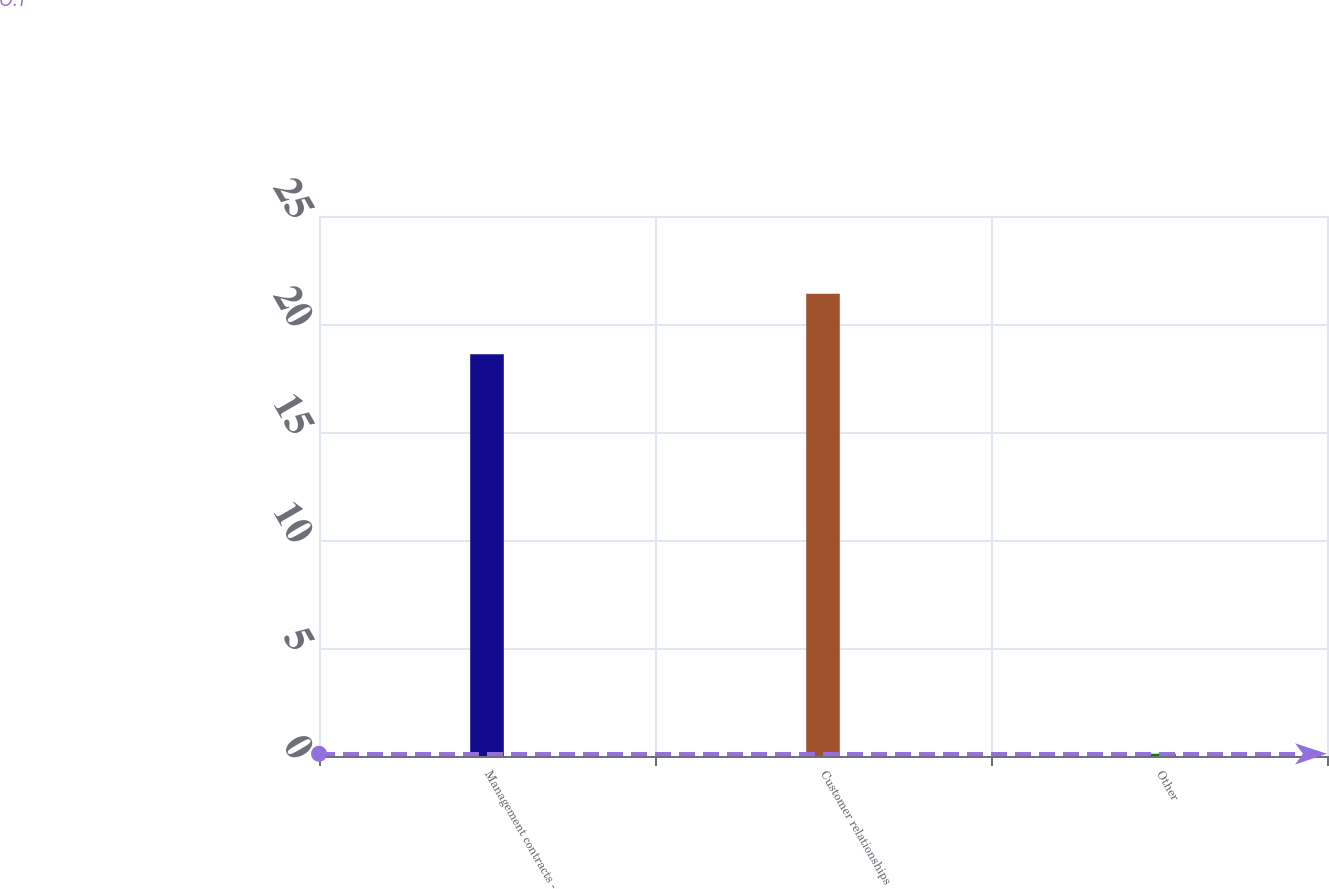Convert chart. <chart><loc_0><loc_0><loc_500><loc_500><bar_chart><fcel>Management contracts -<fcel>Customer relationships<fcel>Other<nl><fcel>18.6<fcel>21.4<fcel>0.1<nl></chart> 